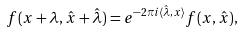Convert formula to latex. <formula><loc_0><loc_0><loc_500><loc_500>f ( x + \lambda , \hat { x } + \hat { \lambda } ) = e ^ { - 2 \pi i \langle \hat { \lambda } , x \rangle } f ( x , \hat { x } ) ,</formula> 